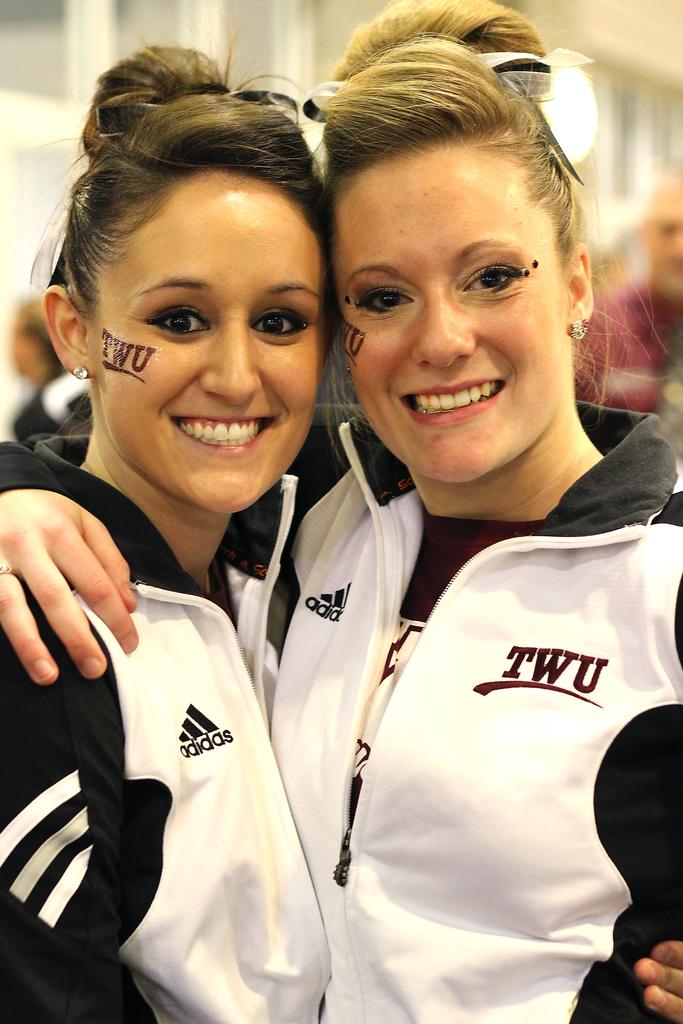What school are they from?
Provide a short and direct response. Twu. 